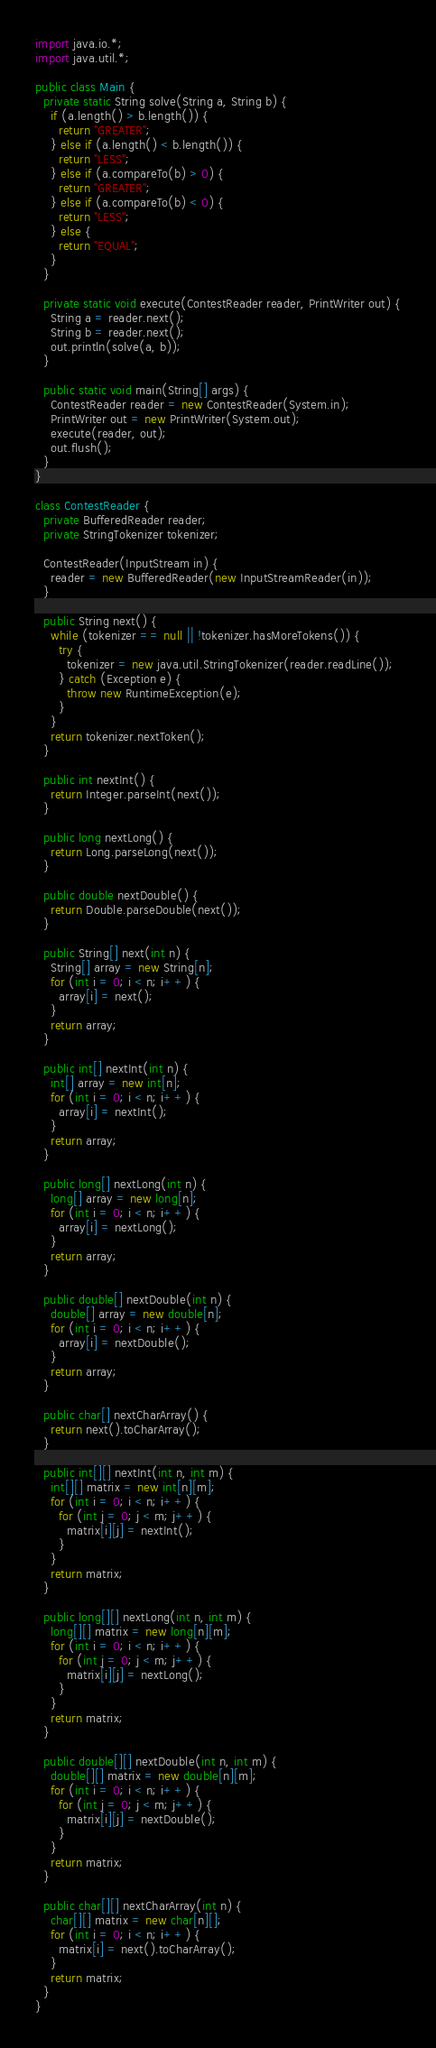<code> <loc_0><loc_0><loc_500><loc_500><_Java_>import java.io.*;
import java.util.*;

public class Main {
  private static String solve(String a, String b) {
    if (a.length() > b.length()) {
      return "GREATER";
    } else if (a.length() < b.length()) {
      return "LESS";
    } else if (a.compareTo(b) > 0) {
      return "GREATER";
    } else if (a.compareTo(b) < 0) {
      return "LESS";
    } else {
      return "EQUAL";
    }
  }
  
  private static void execute(ContestReader reader, PrintWriter out) {
    String a = reader.next();
    String b = reader.next();
    out.println(solve(a, b));
  }
  
  public static void main(String[] args) {
    ContestReader reader = new ContestReader(System.in);
    PrintWriter out = new PrintWriter(System.out);
    execute(reader, out);
    out.flush();
  }
}

class ContestReader {
  private BufferedReader reader;
  private StringTokenizer tokenizer;
  
  ContestReader(InputStream in) {
    reader = new BufferedReader(new InputStreamReader(in));
  }
  
  public String next() {
    while (tokenizer == null || !tokenizer.hasMoreTokens()) {
      try {
        tokenizer = new java.util.StringTokenizer(reader.readLine());
      } catch (Exception e) {
        throw new RuntimeException(e);
      }
    }
    return tokenizer.nextToken();
  }
  
  public int nextInt() {
    return Integer.parseInt(next());
  }
  
  public long nextLong() {
    return Long.parseLong(next());
  }
  
  public double nextDouble() {
    return Double.parseDouble(next());
  }
  
  public String[] next(int n) {
    String[] array = new String[n];
    for (int i = 0; i < n; i++) {
      array[i] = next();
    }
    return array;
  }
  
  public int[] nextInt(int n) {
    int[] array = new int[n];
    for (int i = 0; i < n; i++) {
      array[i] = nextInt();
    }
    return array;
  }
  
  public long[] nextLong(int n) {
    long[] array = new long[n];
    for (int i = 0; i < n; i++) {
      array[i] = nextLong();
    }
    return array;
  }
  
  public double[] nextDouble(int n) {
    double[] array = new double[n];
    for (int i = 0; i < n; i++) {
      array[i] = nextDouble();
    }
    return array;
  }
  
  public char[] nextCharArray() {
    return next().toCharArray();
  }
  
  public int[][] nextInt(int n, int m) {
    int[][] matrix = new int[n][m];
    for (int i = 0; i < n; i++) {
      for (int j = 0; j < m; j++) {
        matrix[i][j] = nextInt();
      }
    }
    return matrix;
  }
  
  public long[][] nextLong(int n, int m) {
    long[][] matrix = new long[n][m];
    for (int i = 0; i < n; i++) {
      for (int j = 0; j < m; j++) {
        matrix[i][j] = nextLong();
      }
    }
    return matrix;
  }
  
  public double[][] nextDouble(int n, int m) {
    double[][] matrix = new double[n][m];
    for (int i = 0; i < n; i++) {
      for (int j = 0; j < m; j++) {
        matrix[i][j] = nextDouble();
      }
    }
    return matrix;
  }
  
  public char[][] nextCharArray(int n) {
    char[][] matrix = new char[n][];
    for (int i = 0; i < n; i++) {
      matrix[i] = next().toCharArray();
    }
    return matrix;
  }
}
</code> 